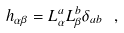Convert formula to latex. <formula><loc_0><loc_0><loc_500><loc_500>h _ { \alpha \beta } = L ^ { a } _ { \alpha } L ^ { b } _ { \beta } \delta _ { a b } \ ,</formula> 